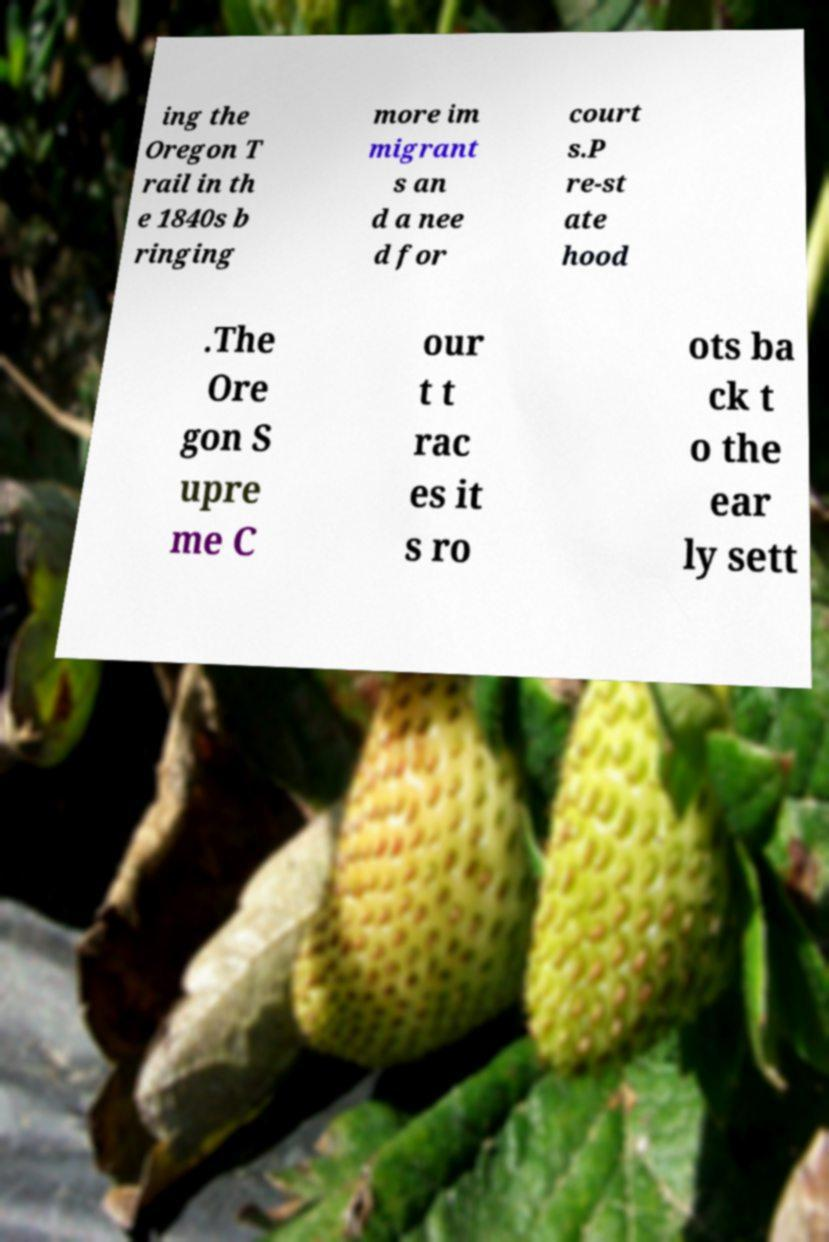Please read and relay the text visible in this image. What does it say? ing the Oregon T rail in th e 1840s b ringing more im migrant s an d a nee d for court s.P re-st ate hood .The Ore gon S upre me C our t t rac es it s ro ots ba ck t o the ear ly sett 